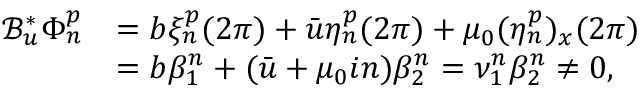<formula> <loc_0><loc_0><loc_500><loc_500>\begin{array} { r l } { \mathcal { B } _ { u } ^ { * } \Phi _ { n } ^ { p } } & { = b \xi _ { n } ^ { p } ( 2 \pi ) + \bar { u } \eta _ { n } ^ { p } ( 2 \pi ) + \mu _ { 0 } ( \eta _ { n } ^ { p } ) _ { x } ( 2 \pi ) } \\ & { = b \beta _ { 1 } ^ { n } + ( \bar { u } + \mu _ { 0 } i n ) \beta _ { 2 } ^ { n } = \nu _ { 1 } ^ { n } \beta _ { 2 } ^ { n } \neq 0 , } \end{array}</formula> 